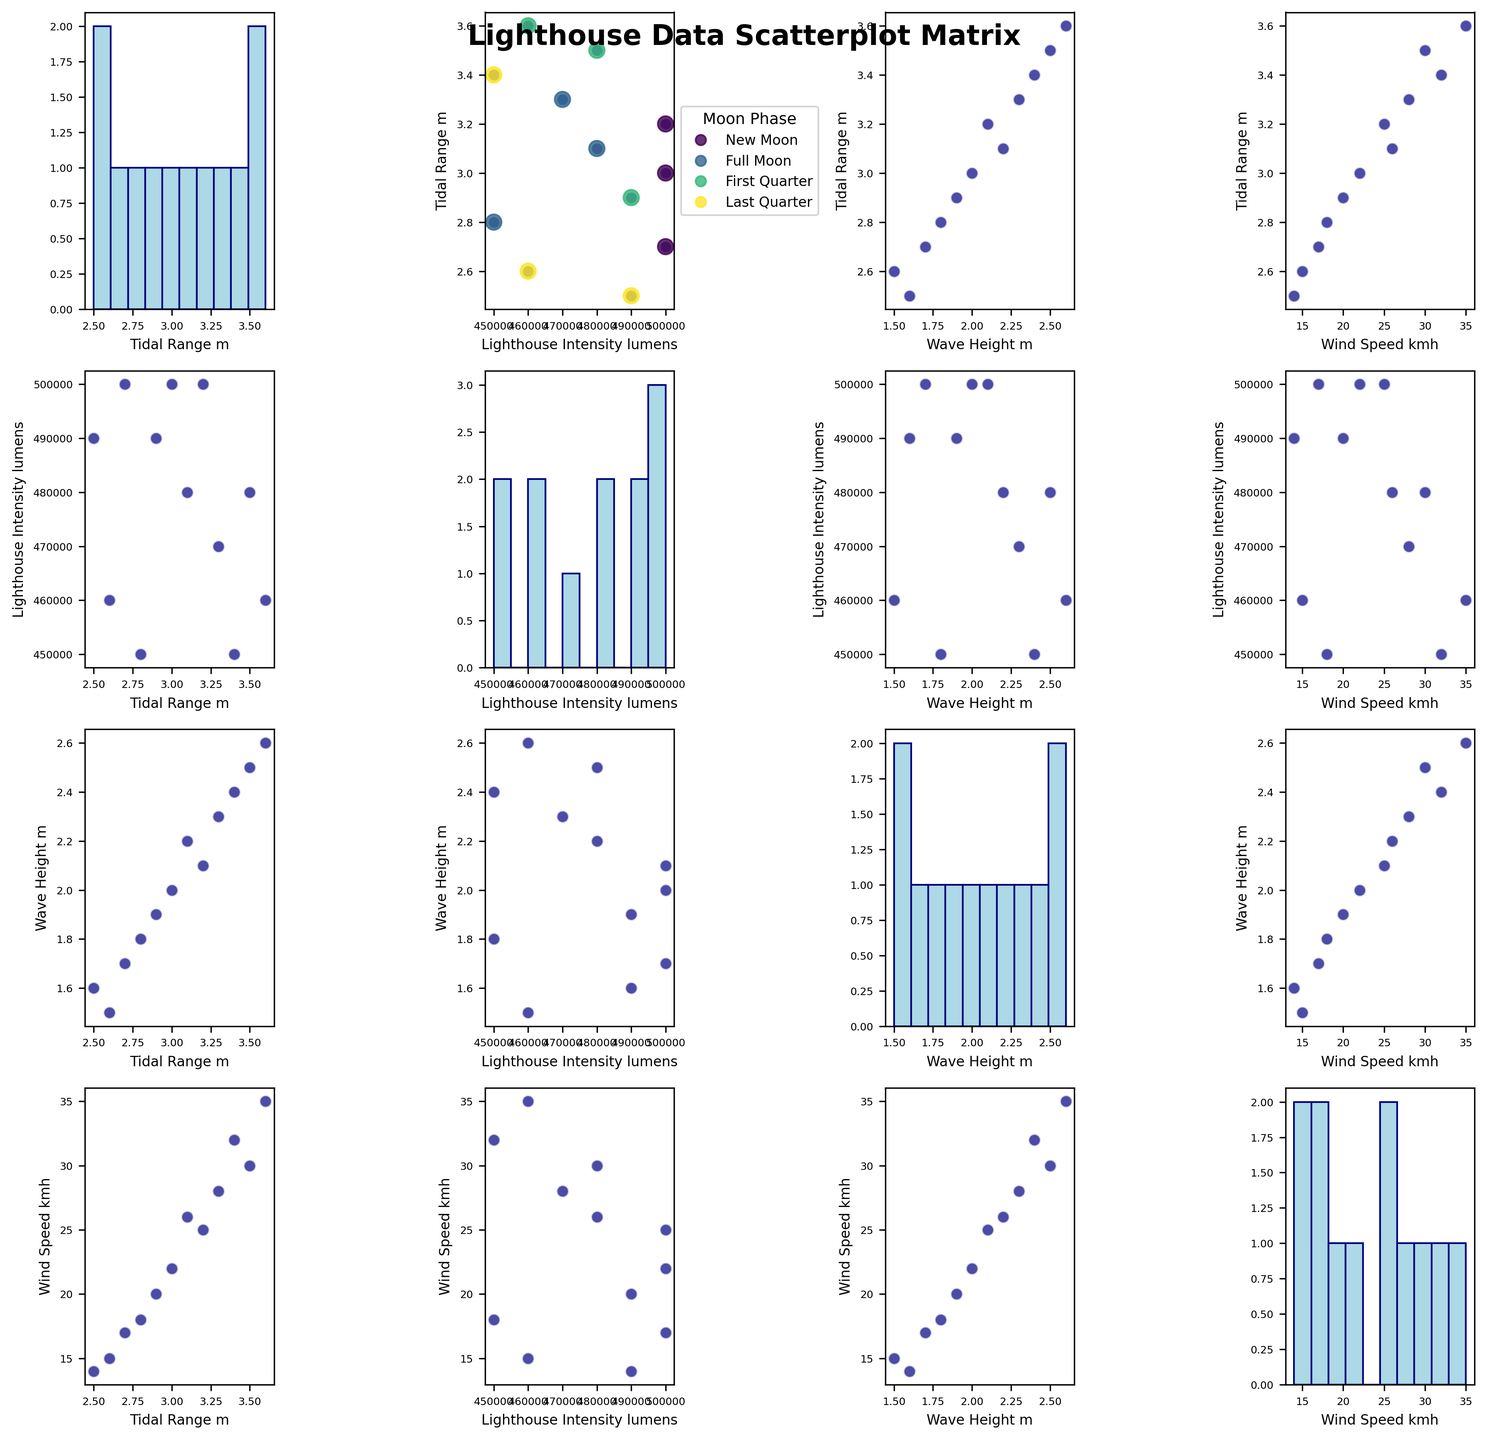What is the title of the figure? The title is located at the top of the scatterplot matrix and provides an overview of the data being visualized.
Answer: "Lighthouse Data Scatterplot Matrix" How are the data points color-coded in the scatterplot of Lighthouse Intensity vs Tidal Range? The scatterplot located at the intersection of the first column and second row is color-coded based on the Moon Phase, as indicated by the legend.
Answer: By Moon Phase Which variable's histogram has the highest peak? By looking at the histograms in the diagonal of the scatterplot matrix, the 'Wind Speed_kmh' histogram in the last column/row has the most pronounced peak.
Answer: Wind Speed_kmh Is there any noticeable correlation between Tidal Range and Wave Height? By inspecting the scatterplot located in the first row and third column, we see that there is no clear linear relationship or pattern between these two variables.
Answer: No noticeable correlation Which Moon Phase corresponds to the highest Tidal Range in the scatterplot of Lighthouse Intensity vs Tidal Range? In the scatterplot located in the first column and second row, observe the data points and their colors to identify that the highest Tidal Range data point corresponds to the "First Quarter" Moon Phase.
Answer: First Quarter What is the average Wave Height for dates with New Moon? Identify the Wave Height values for dates where the Moon Phase is 'New Moon' from the data: 2.1, 2.0, 1.7. Their average is calculated as (2.1 + 2.0 + 1.7)/3 = 1.93
Answer: 1.93 meters Which variable shows the most variation in the histogram? Compare the dispersion/spread of the bars in the histograms across the diagonal of the scatterplot matrix. The 'Wind Speed_kmh' histogram shows the highest variation with a larger spread across different bins.
Answer: Wind Speed_kmh Which Moon Phase category has the least representation in the dataset? Check the scatterplot legend coded by Moon Phase. Determine which color appears the least across all plots. 'Last Quarter' appears fewer times compared to others.
Answer: Last Quarter How many data points have a Tidal Range greater than 3.0 meters in the scatterplot of Tidal Range vs Wind Speed? In the scatterplot at the intersection of the first row and fourth column, count the points having Tidal Range values greater than 3.0 meters. There are five such points.
Answer: 5 Among all pairs of variables, which pair has the closest cluster of points, indicating a potential correlation? By examining the scatterplot matrix, particularly those plots off the diagonal, the scatterplot of 'Wind Speed_kmh' vs 'Tidal Range_m' (fourth row and first column) shows the closest clustering of data points.
Answer: Wind Speed_kmh and Tidal Range_m 